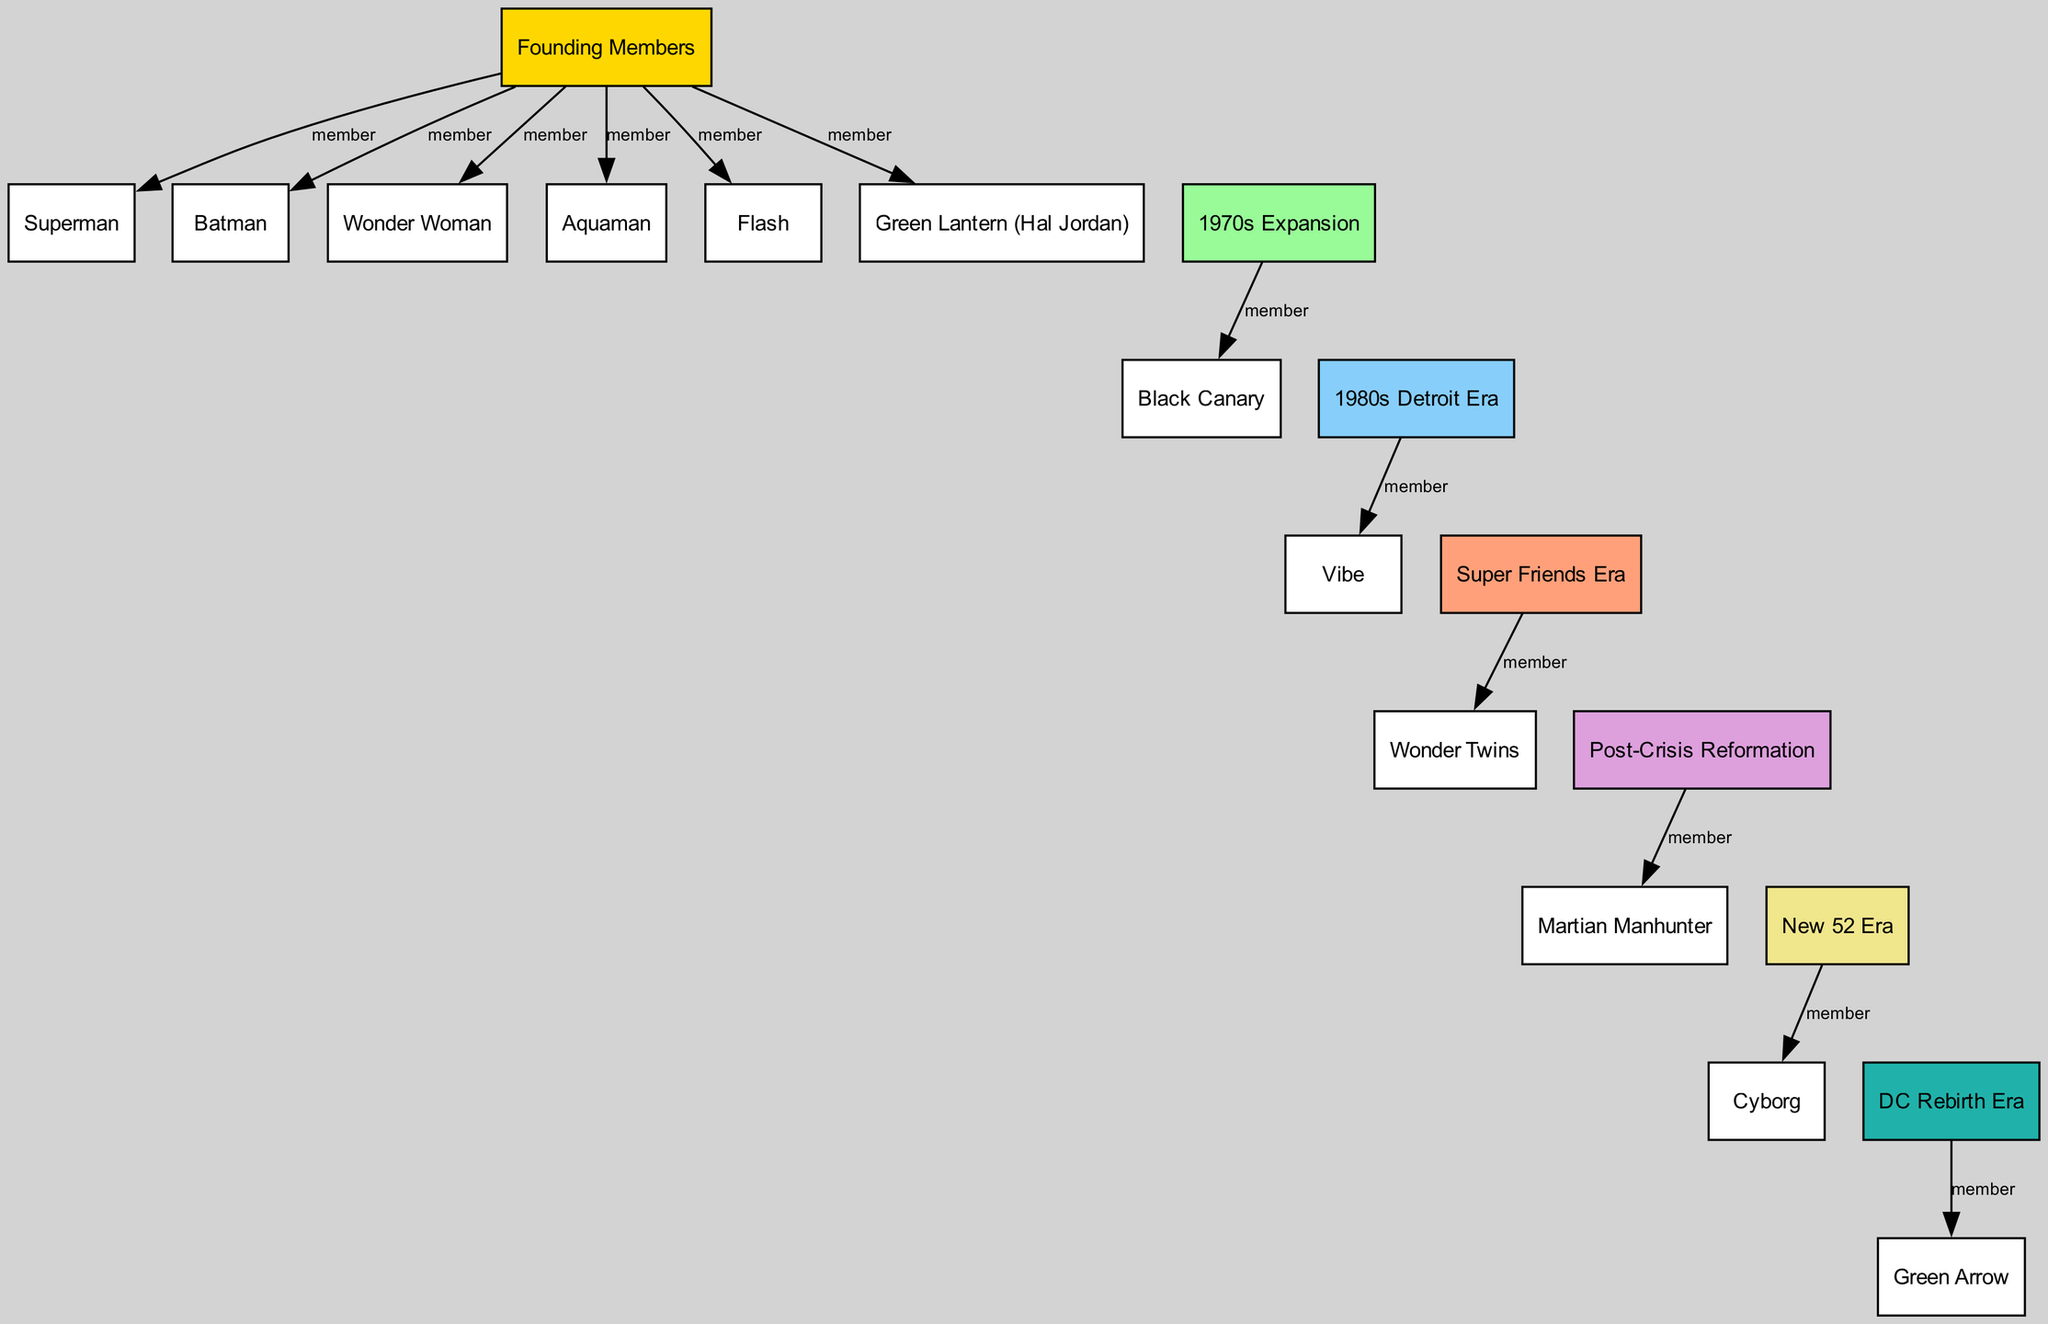What are the founding members of the Justice League? The founding members are visually connected to the "Founding Members" node in the diagram, showing Superman, Batman, Wonder Woman, Aquaman, Flash, and Green Lantern (Hal Jordan). Therefore, they collectively represent the core group of the Justice League.
Answer: Superman, Batman, Wonder Woman, Aquaman, Flash, Green Lantern (Hal Jordan) How many members are shown in the 1970s Expansion? Referring to the "1970s Expansion" node, there is one identified member, Black Canary, visually linked through an edge labeled "member." By counting the edges leading from that node, we confirm that there is only one.
Answer: 1 Which member was added in the 1980s Detroit Era? The diagram indicates that during the 1980s Detroit Era, the member Vibe is noted as being connected to that specific period in the diagram. Thus, Vibe specifically represents a member from the 1980s.
Answer: Vibe What shifts occurred in the Justice League during the Post-Crisis Reformation? The diagram shows that Post-Crisis Reformation introduced Martian Manhunter as a new member, connected through a direct relationship. This indicates a revitalization and restructuring of the team after significant events.
Answer: Martian Manhunter Which era does Cyborg belong to? By tracing the "New 52 Era" node, Cyborg is explicitly indicated as a member linked directly to that era, showing that this was his designated period within the timeline of the Justice League.
Answer: New 52 Era How many eras are represented in the diagram? The diagram contains nodes for different eras: Founders, 1970s Expansion, 1980s Detroit Era, Super Friends Era, Post-Crisis Reformation, New 52 Era, and DC Rebirth Era. Counting these distinct era nodes reveals a total of seven different eras represented.
Answer: 7 Which two members are connected to the Super Friends Era? The diagram highlights the Super Friends Era node and shows a direct connection to the Wonder Twins. Since they are the only noted members in this period, the answer is derived from a direct look at the edges linked to that node.
Answer: Wonder Twins What color signifies the 1980s Detroit Era in the diagram? The node for the 1980s Detroit Era is filled with a specific color, which is blue (87CEFA). This aids in visually distinguishing this era from others in the diagram.
Answer: Blue 